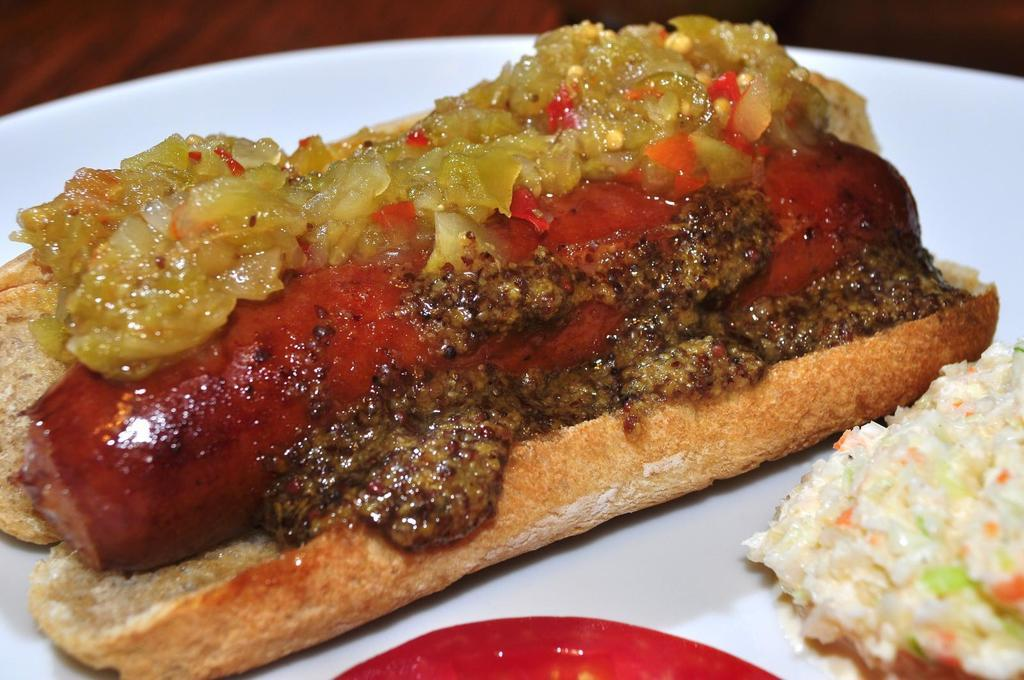What is on the plate in the image? There are food items on a plate in the image. What color is the plate? The plate is white. How many patches are visible on the plate in the image? There are no patches visible on the plate in the image; it is a plain white plate. 